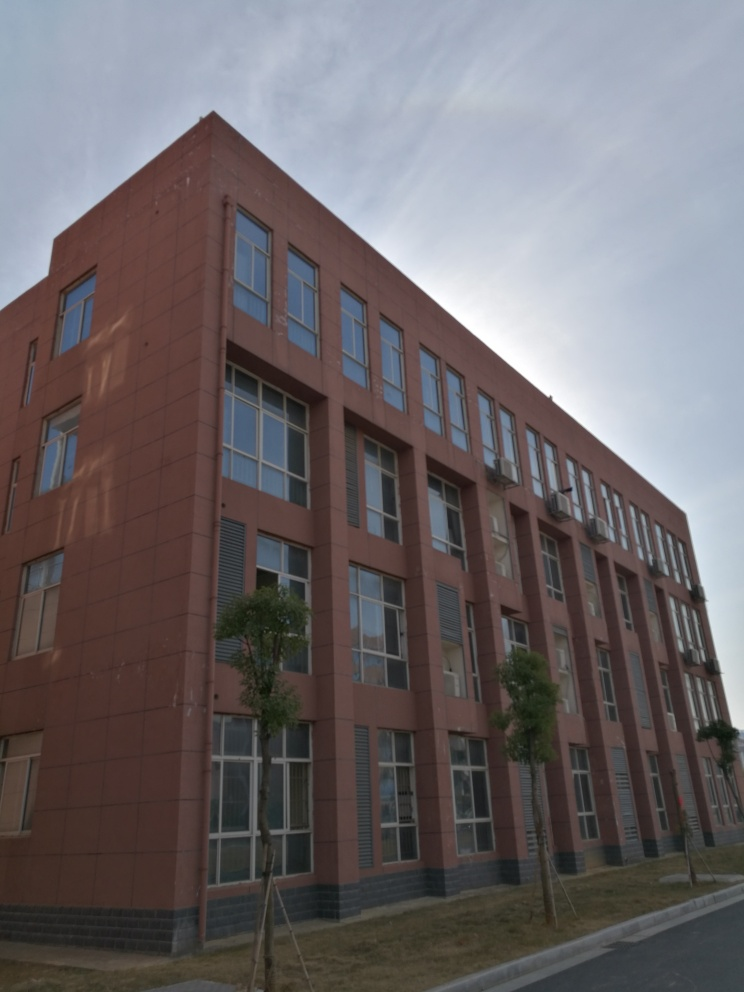What time of day does this photo appear to have been taken? Based on the lighting and shadows present in the photo, it seems to have been taken in the late afternoon when the sun is beginning to lower in the sky, resulting in longer shadows. 